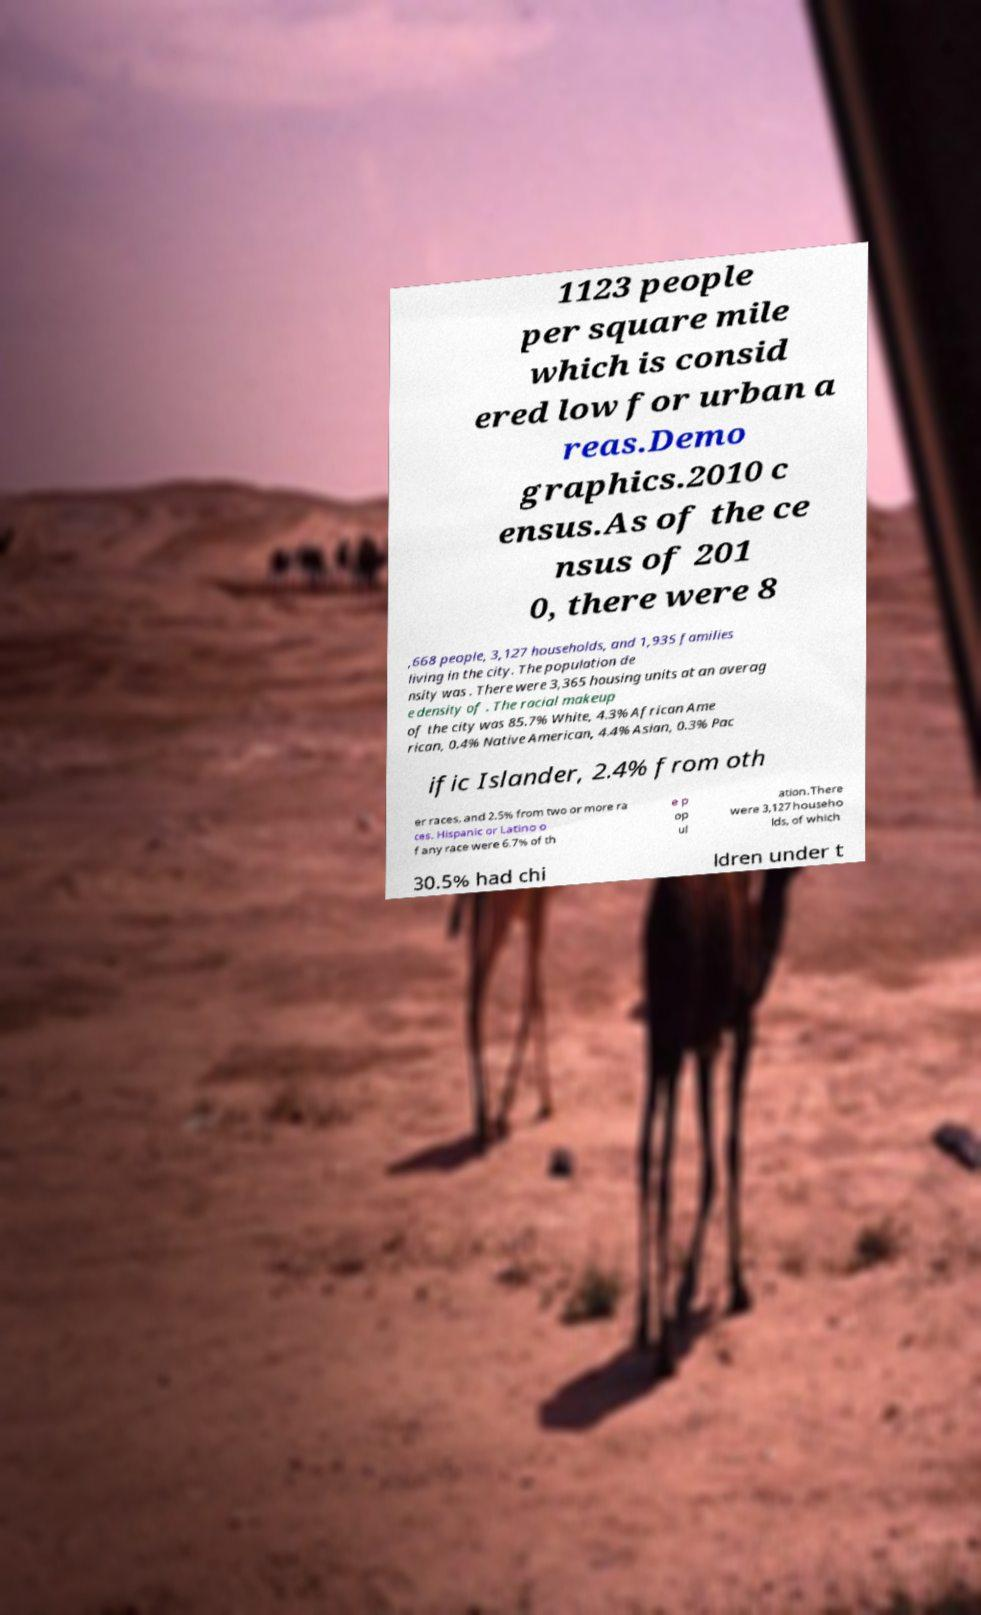For documentation purposes, I need the text within this image transcribed. Could you provide that? 1123 people per square mile which is consid ered low for urban a reas.Demo graphics.2010 c ensus.As of the ce nsus of 201 0, there were 8 ,668 people, 3,127 households, and 1,935 families living in the city. The population de nsity was . There were 3,365 housing units at an averag e density of . The racial makeup of the city was 85.7% White, 4.3% African Ame rican, 0.4% Native American, 4.4% Asian, 0.3% Pac ific Islander, 2.4% from oth er races, and 2.5% from two or more ra ces. Hispanic or Latino o f any race were 6.7% of th e p op ul ation.There were 3,127 househo lds, of which 30.5% had chi ldren under t 